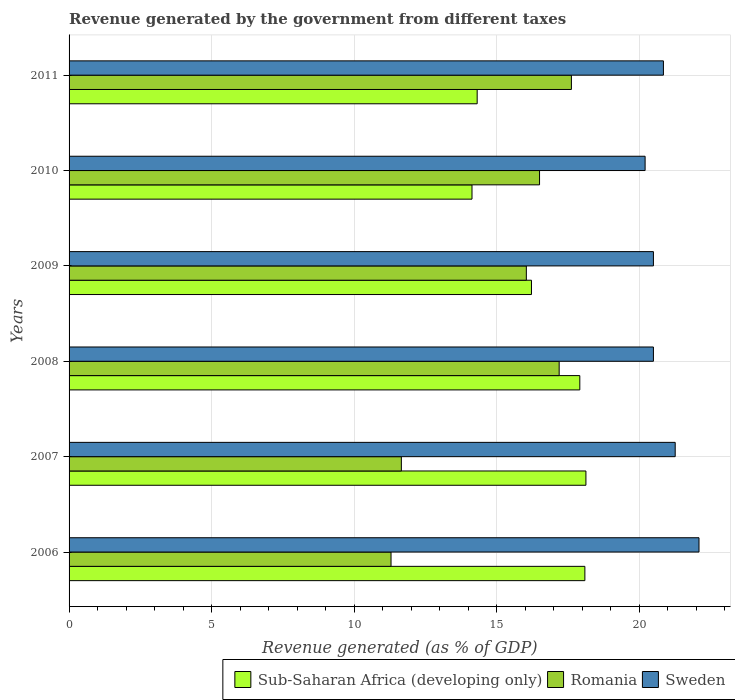How many different coloured bars are there?
Offer a very short reply. 3. How many groups of bars are there?
Keep it short and to the point. 6. Are the number of bars on each tick of the Y-axis equal?
Provide a succinct answer. Yes. How many bars are there on the 2nd tick from the top?
Your answer should be compact. 3. How many bars are there on the 1st tick from the bottom?
Offer a very short reply. 3. In how many cases, is the number of bars for a given year not equal to the number of legend labels?
Offer a terse response. 0. What is the revenue generated by the government in Romania in 2010?
Your answer should be very brief. 16.5. Across all years, what is the maximum revenue generated by the government in Sub-Saharan Africa (developing only)?
Provide a short and direct response. 18.13. Across all years, what is the minimum revenue generated by the government in Sweden?
Make the answer very short. 20.21. In which year was the revenue generated by the government in Sub-Saharan Africa (developing only) maximum?
Your response must be concise. 2007. In which year was the revenue generated by the government in Sweden minimum?
Offer a very short reply. 2010. What is the total revenue generated by the government in Romania in the graph?
Your answer should be compact. 90.3. What is the difference between the revenue generated by the government in Sub-Saharan Africa (developing only) in 2008 and that in 2010?
Keep it short and to the point. 3.78. What is the difference between the revenue generated by the government in Sub-Saharan Africa (developing only) in 2009 and the revenue generated by the government in Sweden in 2008?
Your answer should be compact. -4.28. What is the average revenue generated by the government in Sweden per year?
Your answer should be very brief. 20.9. In the year 2009, what is the difference between the revenue generated by the government in Sub-Saharan Africa (developing only) and revenue generated by the government in Sweden?
Your response must be concise. -4.28. In how many years, is the revenue generated by the government in Sweden greater than 20 %?
Keep it short and to the point. 6. What is the ratio of the revenue generated by the government in Sweden in 2008 to that in 2009?
Your answer should be compact. 1. Is the revenue generated by the government in Sub-Saharan Africa (developing only) in 2009 less than that in 2010?
Make the answer very short. No. Is the difference between the revenue generated by the government in Sub-Saharan Africa (developing only) in 2006 and 2009 greater than the difference between the revenue generated by the government in Sweden in 2006 and 2009?
Keep it short and to the point. Yes. What is the difference between the highest and the second highest revenue generated by the government in Romania?
Offer a terse response. 0.43. What is the difference between the highest and the lowest revenue generated by the government in Sub-Saharan Africa (developing only)?
Provide a short and direct response. 4. Is the sum of the revenue generated by the government in Romania in 2008 and 2010 greater than the maximum revenue generated by the government in Sweden across all years?
Your answer should be compact. Yes. What does the 2nd bar from the top in 2006 represents?
Your response must be concise. Romania. What does the 1st bar from the bottom in 2011 represents?
Give a very brief answer. Sub-Saharan Africa (developing only). Are all the bars in the graph horizontal?
Your answer should be very brief. Yes. What is the difference between two consecutive major ticks on the X-axis?
Give a very brief answer. 5. Does the graph contain any zero values?
Your answer should be compact. No. Where does the legend appear in the graph?
Provide a succinct answer. Bottom right. What is the title of the graph?
Provide a succinct answer. Revenue generated by the government from different taxes. Does "Upper middle income" appear as one of the legend labels in the graph?
Give a very brief answer. No. What is the label or title of the X-axis?
Your response must be concise. Revenue generated (as % of GDP). What is the label or title of the Y-axis?
Provide a short and direct response. Years. What is the Revenue generated (as % of GDP) of Sub-Saharan Africa (developing only) in 2006?
Your answer should be compact. 18.09. What is the Revenue generated (as % of GDP) in Romania in 2006?
Your response must be concise. 11.29. What is the Revenue generated (as % of GDP) in Sweden in 2006?
Your answer should be compact. 22.1. What is the Revenue generated (as % of GDP) of Sub-Saharan Africa (developing only) in 2007?
Provide a succinct answer. 18.13. What is the Revenue generated (as % of GDP) of Romania in 2007?
Give a very brief answer. 11.66. What is the Revenue generated (as % of GDP) of Sweden in 2007?
Your answer should be very brief. 21.26. What is the Revenue generated (as % of GDP) of Sub-Saharan Africa (developing only) in 2008?
Provide a short and direct response. 17.92. What is the Revenue generated (as % of GDP) in Romania in 2008?
Your answer should be very brief. 17.19. What is the Revenue generated (as % of GDP) in Sweden in 2008?
Offer a very short reply. 20.5. What is the Revenue generated (as % of GDP) of Sub-Saharan Africa (developing only) in 2009?
Provide a short and direct response. 16.22. What is the Revenue generated (as % of GDP) of Romania in 2009?
Offer a very short reply. 16.04. What is the Revenue generated (as % of GDP) of Sweden in 2009?
Offer a very short reply. 20.5. What is the Revenue generated (as % of GDP) in Sub-Saharan Africa (developing only) in 2010?
Your response must be concise. 14.13. What is the Revenue generated (as % of GDP) of Romania in 2010?
Give a very brief answer. 16.5. What is the Revenue generated (as % of GDP) in Sweden in 2010?
Make the answer very short. 20.21. What is the Revenue generated (as % of GDP) in Sub-Saharan Africa (developing only) in 2011?
Provide a short and direct response. 14.31. What is the Revenue generated (as % of GDP) of Romania in 2011?
Your answer should be compact. 17.62. What is the Revenue generated (as % of GDP) of Sweden in 2011?
Your answer should be compact. 20.85. Across all years, what is the maximum Revenue generated (as % of GDP) in Sub-Saharan Africa (developing only)?
Provide a succinct answer. 18.13. Across all years, what is the maximum Revenue generated (as % of GDP) in Romania?
Offer a terse response. 17.62. Across all years, what is the maximum Revenue generated (as % of GDP) of Sweden?
Provide a succinct answer. 22.1. Across all years, what is the minimum Revenue generated (as % of GDP) in Sub-Saharan Africa (developing only)?
Provide a short and direct response. 14.13. Across all years, what is the minimum Revenue generated (as % of GDP) in Romania?
Provide a short and direct response. 11.29. Across all years, what is the minimum Revenue generated (as % of GDP) of Sweden?
Provide a short and direct response. 20.21. What is the total Revenue generated (as % of GDP) in Sub-Saharan Africa (developing only) in the graph?
Your answer should be compact. 98.81. What is the total Revenue generated (as % of GDP) of Romania in the graph?
Your answer should be compact. 90.3. What is the total Revenue generated (as % of GDP) in Sweden in the graph?
Your answer should be very brief. 125.41. What is the difference between the Revenue generated (as % of GDP) in Sub-Saharan Africa (developing only) in 2006 and that in 2007?
Make the answer very short. -0.04. What is the difference between the Revenue generated (as % of GDP) in Romania in 2006 and that in 2007?
Give a very brief answer. -0.36. What is the difference between the Revenue generated (as % of GDP) in Sweden in 2006 and that in 2007?
Offer a terse response. 0.83. What is the difference between the Revenue generated (as % of GDP) of Sub-Saharan Africa (developing only) in 2006 and that in 2008?
Provide a short and direct response. 0.18. What is the difference between the Revenue generated (as % of GDP) of Romania in 2006 and that in 2008?
Provide a succinct answer. -5.9. What is the difference between the Revenue generated (as % of GDP) of Sweden in 2006 and that in 2008?
Offer a very short reply. 1.6. What is the difference between the Revenue generated (as % of GDP) of Sub-Saharan Africa (developing only) in 2006 and that in 2009?
Your response must be concise. 1.87. What is the difference between the Revenue generated (as % of GDP) of Romania in 2006 and that in 2009?
Your response must be concise. -4.75. What is the difference between the Revenue generated (as % of GDP) in Sweden in 2006 and that in 2009?
Offer a very short reply. 1.6. What is the difference between the Revenue generated (as % of GDP) of Sub-Saharan Africa (developing only) in 2006 and that in 2010?
Ensure brevity in your answer.  3.96. What is the difference between the Revenue generated (as % of GDP) in Romania in 2006 and that in 2010?
Your answer should be very brief. -5.21. What is the difference between the Revenue generated (as % of GDP) in Sweden in 2006 and that in 2010?
Provide a succinct answer. 1.89. What is the difference between the Revenue generated (as % of GDP) of Sub-Saharan Africa (developing only) in 2006 and that in 2011?
Your answer should be very brief. 3.78. What is the difference between the Revenue generated (as % of GDP) in Romania in 2006 and that in 2011?
Your answer should be compact. -6.33. What is the difference between the Revenue generated (as % of GDP) in Sweden in 2006 and that in 2011?
Keep it short and to the point. 1.25. What is the difference between the Revenue generated (as % of GDP) in Sub-Saharan Africa (developing only) in 2007 and that in 2008?
Make the answer very short. 0.21. What is the difference between the Revenue generated (as % of GDP) of Romania in 2007 and that in 2008?
Offer a very short reply. -5.54. What is the difference between the Revenue generated (as % of GDP) in Sweden in 2007 and that in 2008?
Give a very brief answer. 0.76. What is the difference between the Revenue generated (as % of GDP) of Sub-Saharan Africa (developing only) in 2007 and that in 2009?
Keep it short and to the point. 1.91. What is the difference between the Revenue generated (as % of GDP) in Romania in 2007 and that in 2009?
Your answer should be very brief. -4.38. What is the difference between the Revenue generated (as % of GDP) in Sweden in 2007 and that in 2009?
Your answer should be very brief. 0.76. What is the difference between the Revenue generated (as % of GDP) of Sub-Saharan Africa (developing only) in 2007 and that in 2010?
Your answer should be compact. 4. What is the difference between the Revenue generated (as % of GDP) of Romania in 2007 and that in 2010?
Your response must be concise. -4.85. What is the difference between the Revenue generated (as % of GDP) of Sweden in 2007 and that in 2010?
Ensure brevity in your answer.  1.06. What is the difference between the Revenue generated (as % of GDP) of Sub-Saharan Africa (developing only) in 2007 and that in 2011?
Ensure brevity in your answer.  3.81. What is the difference between the Revenue generated (as % of GDP) of Romania in 2007 and that in 2011?
Provide a short and direct response. -5.96. What is the difference between the Revenue generated (as % of GDP) of Sweden in 2007 and that in 2011?
Your answer should be compact. 0.41. What is the difference between the Revenue generated (as % of GDP) of Sub-Saharan Africa (developing only) in 2008 and that in 2009?
Your answer should be very brief. 1.7. What is the difference between the Revenue generated (as % of GDP) of Romania in 2008 and that in 2009?
Offer a very short reply. 1.15. What is the difference between the Revenue generated (as % of GDP) in Sweden in 2008 and that in 2009?
Make the answer very short. 0. What is the difference between the Revenue generated (as % of GDP) of Sub-Saharan Africa (developing only) in 2008 and that in 2010?
Provide a succinct answer. 3.78. What is the difference between the Revenue generated (as % of GDP) in Romania in 2008 and that in 2010?
Ensure brevity in your answer.  0.69. What is the difference between the Revenue generated (as % of GDP) of Sweden in 2008 and that in 2010?
Offer a very short reply. 0.29. What is the difference between the Revenue generated (as % of GDP) in Sub-Saharan Africa (developing only) in 2008 and that in 2011?
Your answer should be very brief. 3.6. What is the difference between the Revenue generated (as % of GDP) of Romania in 2008 and that in 2011?
Offer a very short reply. -0.43. What is the difference between the Revenue generated (as % of GDP) in Sweden in 2008 and that in 2011?
Make the answer very short. -0.35. What is the difference between the Revenue generated (as % of GDP) in Sub-Saharan Africa (developing only) in 2009 and that in 2010?
Offer a very short reply. 2.09. What is the difference between the Revenue generated (as % of GDP) of Romania in 2009 and that in 2010?
Your answer should be very brief. -0.46. What is the difference between the Revenue generated (as % of GDP) in Sweden in 2009 and that in 2010?
Provide a succinct answer. 0.29. What is the difference between the Revenue generated (as % of GDP) in Sub-Saharan Africa (developing only) in 2009 and that in 2011?
Provide a short and direct response. 1.9. What is the difference between the Revenue generated (as % of GDP) in Romania in 2009 and that in 2011?
Provide a succinct answer. -1.58. What is the difference between the Revenue generated (as % of GDP) in Sweden in 2009 and that in 2011?
Make the answer very short. -0.35. What is the difference between the Revenue generated (as % of GDP) of Sub-Saharan Africa (developing only) in 2010 and that in 2011?
Keep it short and to the point. -0.18. What is the difference between the Revenue generated (as % of GDP) in Romania in 2010 and that in 2011?
Provide a succinct answer. -1.12. What is the difference between the Revenue generated (as % of GDP) in Sweden in 2010 and that in 2011?
Offer a very short reply. -0.64. What is the difference between the Revenue generated (as % of GDP) in Sub-Saharan Africa (developing only) in 2006 and the Revenue generated (as % of GDP) in Romania in 2007?
Offer a terse response. 6.44. What is the difference between the Revenue generated (as % of GDP) in Sub-Saharan Africa (developing only) in 2006 and the Revenue generated (as % of GDP) in Sweden in 2007?
Offer a terse response. -3.17. What is the difference between the Revenue generated (as % of GDP) of Romania in 2006 and the Revenue generated (as % of GDP) of Sweden in 2007?
Keep it short and to the point. -9.97. What is the difference between the Revenue generated (as % of GDP) in Sub-Saharan Africa (developing only) in 2006 and the Revenue generated (as % of GDP) in Romania in 2008?
Offer a very short reply. 0.9. What is the difference between the Revenue generated (as % of GDP) in Sub-Saharan Africa (developing only) in 2006 and the Revenue generated (as % of GDP) in Sweden in 2008?
Your answer should be compact. -2.4. What is the difference between the Revenue generated (as % of GDP) of Romania in 2006 and the Revenue generated (as % of GDP) of Sweden in 2008?
Your response must be concise. -9.2. What is the difference between the Revenue generated (as % of GDP) in Sub-Saharan Africa (developing only) in 2006 and the Revenue generated (as % of GDP) in Romania in 2009?
Keep it short and to the point. 2.05. What is the difference between the Revenue generated (as % of GDP) of Sub-Saharan Africa (developing only) in 2006 and the Revenue generated (as % of GDP) of Sweden in 2009?
Provide a short and direct response. -2.4. What is the difference between the Revenue generated (as % of GDP) of Romania in 2006 and the Revenue generated (as % of GDP) of Sweden in 2009?
Make the answer very short. -9.2. What is the difference between the Revenue generated (as % of GDP) of Sub-Saharan Africa (developing only) in 2006 and the Revenue generated (as % of GDP) of Romania in 2010?
Your answer should be very brief. 1.59. What is the difference between the Revenue generated (as % of GDP) in Sub-Saharan Africa (developing only) in 2006 and the Revenue generated (as % of GDP) in Sweden in 2010?
Offer a very short reply. -2.11. What is the difference between the Revenue generated (as % of GDP) in Romania in 2006 and the Revenue generated (as % of GDP) in Sweden in 2010?
Give a very brief answer. -8.91. What is the difference between the Revenue generated (as % of GDP) in Sub-Saharan Africa (developing only) in 2006 and the Revenue generated (as % of GDP) in Romania in 2011?
Make the answer very short. 0.47. What is the difference between the Revenue generated (as % of GDP) of Sub-Saharan Africa (developing only) in 2006 and the Revenue generated (as % of GDP) of Sweden in 2011?
Keep it short and to the point. -2.75. What is the difference between the Revenue generated (as % of GDP) of Romania in 2006 and the Revenue generated (as % of GDP) of Sweden in 2011?
Offer a very short reply. -9.55. What is the difference between the Revenue generated (as % of GDP) in Sub-Saharan Africa (developing only) in 2007 and the Revenue generated (as % of GDP) in Romania in 2008?
Offer a terse response. 0.94. What is the difference between the Revenue generated (as % of GDP) of Sub-Saharan Africa (developing only) in 2007 and the Revenue generated (as % of GDP) of Sweden in 2008?
Provide a succinct answer. -2.37. What is the difference between the Revenue generated (as % of GDP) in Romania in 2007 and the Revenue generated (as % of GDP) in Sweden in 2008?
Provide a succinct answer. -8.84. What is the difference between the Revenue generated (as % of GDP) of Sub-Saharan Africa (developing only) in 2007 and the Revenue generated (as % of GDP) of Romania in 2009?
Make the answer very short. 2.09. What is the difference between the Revenue generated (as % of GDP) of Sub-Saharan Africa (developing only) in 2007 and the Revenue generated (as % of GDP) of Sweden in 2009?
Offer a very short reply. -2.37. What is the difference between the Revenue generated (as % of GDP) of Romania in 2007 and the Revenue generated (as % of GDP) of Sweden in 2009?
Provide a succinct answer. -8.84. What is the difference between the Revenue generated (as % of GDP) in Sub-Saharan Africa (developing only) in 2007 and the Revenue generated (as % of GDP) in Romania in 2010?
Your answer should be compact. 1.63. What is the difference between the Revenue generated (as % of GDP) in Sub-Saharan Africa (developing only) in 2007 and the Revenue generated (as % of GDP) in Sweden in 2010?
Offer a terse response. -2.08. What is the difference between the Revenue generated (as % of GDP) in Romania in 2007 and the Revenue generated (as % of GDP) in Sweden in 2010?
Your answer should be very brief. -8.55. What is the difference between the Revenue generated (as % of GDP) of Sub-Saharan Africa (developing only) in 2007 and the Revenue generated (as % of GDP) of Romania in 2011?
Give a very brief answer. 0.51. What is the difference between the Revenue generated (as % of GDP) in Sub-Saharan Africa (developing only) in 2007 and the Revenue generated (as % of GDP) in Sweden in 2011?
Offer a terse response. -2.72. What is the difference between the Revenue generated (as % of GDP) of Romania in 2007 and the Revenue generated (as % of GDP) of Sweden in 2011?
Keep it short and to the point. -9.19. What is the difference between the Revenue generated (as % of GDP) in Sub-Saharan Africa (developing only) in 2008 and the Revenue generated (as % of GDP) in Romania in 2009?
Provide a short and direct response. 1.88. What is the difference between the Revenue generated (as % of GDP) in Sub-Saharan Africa (developing only) in 2008 and the Revenue generated (as % of GDP) in Sweden in 2009?
Your response must be concise. -2.58. What is the difference between the Revenue generated (as % of GDP) in Romania in 2008 and the Revenue generated (as % of GDP) in Sweden in 2009?
Offer a very short reply. -3.31. What is the difference between the Revenue generated (as % of GDP) in Sub-Saharan Africa (developing only) in 2008 and the Revenue generated (as % of GDP) in Romania in 2010?
Ensure brevity in your answer.  1.41. What is the difference between the Revenue generated (as % of GDP) of Sub-Saharan Africa (developing only) in 2008 and the Revenue generated (as % of GDP) of Sweden in 2010?
Provide a short and direct response. -2.29. What is the difference between the Revenue generated (as % of GDP) in Romania in 2008 and the Revenue generated (as % of GDP) in Sweden in 2010?
Your answer should be compact. -3.01. What is the difference between the Revenue generated (as % of GDP) of Sub-Saharan Africa (developing only) in 2008 and the Revenue generated (as % of GDP) of Romania in 2011?
Offer a very short reply. 0.29. What is the difference between the Revenue generated (as % of GDP) of Sub-Saharan Africa (developing only) in 2008 and the Revenue generated (as % of GDP) of Sweden in 2011?
Offer a very short reply. -2.93. What is the difference between the Revenue generated (as % of GDP) of Romania in 2008 and the Revenue generated (as % of GDP) of Sweden in 2011?
Ensure brevity in your answer.  -3.66. What is the difference between the Revenue generated (as % of GDP) in Sub-Saharan Africa (developing only) in 2009 and the Revenue generated (as % of GDP) in Romania in 2010?
Provide a succinct answer. -0.28. What is the difference between the Revenue generated (as % of GDP) of Sub-Saharan Africa (developing only) in 2009 and the Revenue generated (as % of GDP) of Sweden in 2010?
Offer a very short reply. -3.99. What is the difference between the Revenue generated (as % of GDP) of Romania in 2009 and the Revenue generated (as % of GDP) of Sweden in 2010?
Your response must be concise. -4.17. What is the difference between the Revenue generated (as % of GDP) in Sub-Saharan Africa (developing only) in 2009 and the Revenue generated (as % of GDP) in Romania in 2011?
Provide a succinct answer. -1.4. What is the difference between the Revenue generated (as % of GDP) of Sub-Saharan Africa (developing only) in 2009 and the Revenue generated (as % of GDP) of Sweden in 2011?
Your response must be concise. -4.63. What is the difference between the Revenue generated (as % of GDP) of Romania in 2009 and the Revenue generated (as % of GDP) of Sweden in 2011?
Offer a very short reply. -4.81. What is the difference between the Revenue generated (as % of GDP) in Sub-Saharan Africa (developing only) in 2010 and the Revenue generated (as % of GDP) in Romania in 2011?
Provide a short and direct response. -3.49. What is the difference between the Revenue generated (as % of GDP) of Sub-Saharan Africa (developing only) in 2010 and the Revenue generated (as % of GDP) of Sweden in 2011?
Make the answer very short. -6.71. What is the difference between the Revenue generated (as % of GDP) of Romania in 2010 and the Revenue generated (as % of GDP) of Sweden in 2011?
Give a very brief answer. -4.34. What is the average Revenue generated (as % of GDP) in Sub-Saharan Africa (developing only) per year?
Offer a very short reply. 16.47. What is the average Revenue generated (as % of GDP) in Romania per year?
Provide a short and direct response. 15.05. What is the average Revenue generated (as % of GDP) in Sweden per year?
Offer a terse response. 20.9. In the year 2006, what is the difference between the Revenue generated (as % of GDP) in Sub-Saharan Africa (developing only) and Revenue generated (as % of GDP) in Romania?
Offer a terse response. 6.8. In the year 2006, what is the difference between the Revenue generated (as % of GDP) in Sub-Saharan Africa (developing only) and Revenue generated (as % of GDP) in Sweden?
Your answer should be very brief. -4. In the year 2006, what is the difference between the Revenue generated (as % of GDP) of Romania and Revenue generated (as % of GDP) of Sweden?
Ensure brevity in your answer.  -10.8. In the year 2007, what is the difference between the Revenue generated (as % of GDP) of Sub-Saharan Africa (developing only) and Revenue generated (as % of GDP) of Romania?
Provide a short and direct response. 6.47. In the year 2007, what is the difference between the Revenue generated (as % of GDP) of Sub-Saharan Africa (developing only) and Revenue generated (as % of GDP) of Sweden?
Your answer should be very brief. -3.13. In the year 2007, what is the difference between the Revenue generated (as % of GDP) of Romania and Revenue generated (as % of GDP) of Sweden?
Offer a terse response. -9.61. In the year 2008, what is the difference between the Revenue generated (as % of GDP) in Sub-Saharan Africa (developing only) and Revenue generated (as % of GDP) in Romania?
Offer a terse response. 0.72. In the year 2008, what is the difference between the Revenue generated (as % of GDP) of Sub-Saharan Africa (developing only) and Revenue generated (as % of GDP) of Sweden?
Keep it short and to the point. -2.58. In the year 2008, what is the difference between the Revenue generated (as % of GDP) in Romania and Revenue generated (as % of GDP) in Sweden?
Keep it short and to the point. -3.31. In the year 2009, what is the difference between the Revenue generated (as % of GDP) in Sub-Saharan Africa (developing only) and Revenue generated (as % of GDP) in Romania?
Offer a terse response. 0.18. In the year 2009, what is the difference between the Revenue generated (as % of GDP) in Sub-Saharan Africa (developing only) and Revenue generated (as % of GDP) in Sweden?
Your answer should be very brief. -4.28. In the year 2009, what is the difference between the Revenue generated (as % of GDP) in Romania and Revenue generated (as % of GDP) in Sweden?
Your response must be concise. -4.46. In the year 2010, what is the difference between the Revenue generated (as % of GDP) in Sub-Saharan Africa (developing only) and Revenue generated (as % of GDP) in Romania?
Your answer should be compact. -2.37. In the year 2010, what is the difference between the Revenue generated (as % of GDP) in Sub-Saharan Africa (developing only) and Revenue generated (as % of GDP) in Sweden?
Provide a succinct answer. -6.07. In the year 2010, what is the difference between the Revenue generated (as % of GDP) in Romania and Revenue generated (as % of GDP) in Sweden?
Offer a terse response. -3.7. In the year 2011, what is the difference between the Revenue generated (as % of GDP) in Sub-Saharan Africa (developing only) and Revenue generated (as % of GDP) in Romania?
Offer a very short reply. -3.31. In the year 2011, what is the difference between the Revenue generated (as % of GDP) of Sub-Saharan Africa (developing only) and Revenue generated (as % of GDP) of Sweden?
Ensure brevity in your answer.  -6.53. In the year 2011, what is the difference between the Revenue generated (as % of GDP) of Romania and Revenue generated (as % of GDP) of Sweden?
Give a very brief answer. -3.23. What is the ratio of the Revenue generated (as % of GDP) in Sub-Saharan Africa (developing only) in 2006 to that in 2007?
Your response must be concise. 1. What is the ratio of the Revenue generated (as % of GDP) in Romania in 2006 to that in 2007?
Your answer should be compact. 0.97. What is the ratio of the Revenue generated (as % of GDP) of Sweden in 2006 to that in 2007?
Keep it short and to the point. 1.04. What is the ratio of the Revenue generated (as % of GDP) of Sub-Saharan Africa (developing only) in 2006 to that in 2008?
Your response must be concise. 1.01. What is the ratio of the Revenue generated (as % of GDP) of Romania in 2006 to that in 2008?
Provide a short and direct response. 0.66. What is the ratio of the Revenue generated (as % of GDP) in Sweden in 2006 to that in 2008?
Ensure brevity in your answer.  1.08. What is the ratio of the Revenue generated (as % of GDP) of Sub-Saharan Africa (developing only) in 2006 to that in 2009?
Your answer should be compact. 1.12. What is the ratio of the Revenue generated (as % of GDP) in Romania in 2006 to that in 2009?
Ensure brevity in your answer.  0.7. What is the ratio of the Revenue generated (as % of GDP) of Sweden in 2006 to that in 2009?
Your answer should be compact. 1.08. What is the ratio of the Revenue generated (as % of GDP) of Sub-Saharan Africa (developing only) in 2006 to that in 2010?
Provide a succinct answer. 1.28. What is the ratio of the Revenue generated (as % of GDP) of Romania in 2006 to that in 2010?
Provide a succinct answer. 0.68. What is the ratio of the Revenue generated (as % of GDP) of Sweden in 2006 to that in 2010?
Provide a short and direct response. 1.09. What is the ratio of the Revenue generated (as % of GDP) of Sub-Saharan Africa (developing only) in 2006 to that in 2011?
Ensure brevity in your answer.  1.26. What is the ratio of the Revenue generated (as % of GDP) in Romania in 2006 to that in 2011?
Offer a very short reply. 0.64. What is the ratio of the Revenue generated (as % of GDP) in Sweden in 2006 to that in 2011?
Your answer should be very brief. 1.06. What is the ratio of the Revenue generated (as % of GDP) of Sub-Saharan Africa (developing only) in 2007 to that in 2008?
Ensure brevity in your answer.  1.01. What is the ratio of the Revenue generated (as % of GDP) of Romania in 2007 to that in 2008?
Make the answer very short. 0.68. What is the ratio of the Revenue generated (as % of GDP) of Sweden in 2007 to that in 2008?
Give a very brief answer. 1.04. What is the ratio of the Revenue generated (as % of GDP) of Sub-Saharan Africa (developing only) in 2007 to that in 2009?
Give a very brief answer. 1.12. What is the ratio of the Revenue generated (as % of GDP) in Romania in 2007 to that in 2009?
Offer a very short reply. 0.73. What is the ratio of the Revenue generated (as % of GDP) in Sweden in 2007 to that in 2009?
Ensure brevity in your answer.  1.04. What is the ratio of the Revenue generated (as % of GDP) in Sub-Saharan Africa (developing only) in 2007 to that in 2010?
Offer a very short reply. 1.28. What is the ratio of the Revenue generated (as % of GDP) of Romania in 2007 to that in 2010?
Keep it short and to the point. 0.71. What is the ratio of the Revenue generated (as % of GDP) in Sweden in 2007 to that in 2010?
Your answer should be compact. 1.05. What is the ratio of the Revenue generated (as % of GDP) in Sub-Saharan Africa (developing only) in 2007 to that in 2011?
Offer a very short reply. 1.27. What is the ratio of the Revenue generated (as % of GDP) of Romania in 2007 to that in 2011?
Offer a terse response. 0.66. What is the ratio of the Revenue generated (as % of GDP) in Sweden in 2007 to that in 2011?
Your answer should be very brief. 1.02. What is the ratio of the Revenue generated (as % of GDP) in Sub-Saharan Africa (developing only) in 2008 to that in 2009?
Provide a succinct answer. 1.1. What is the ratio of the Revenue generated (as % of GDP) in Romania in 2008 to that in 2009?
Make the answer very short. 1.07. What is the ratio of the Revenue generated (as % of GDP) of Sweden in 2008 to that in 2009?
Provide a succinct answer. 1. What is the ratio of the Revenue generated (as % of GDP) in Sub-Saharan Africa (developing only) in 2008 to that in 2010?
Give a very brief answer. 1.27. What is the ratio of the Revenue generated (as % of GDP) in Romania in 2008 to that in 2010?
Your response must be concise. 1.04. What is the ratio of the Revenue generated (as % of GDP) in Sweden in 2008 to that in 2010?
Provide a succinct answer. 1.01. What is the ratio of the Revenue generated (as % of GDP) of Sub-Saharan Africa (developing only) in 2008 to that in 2011?
Provide a short and direct response. 1.25. What is the ratio of the Revenue generated (as % of GDP) in Romania in 2008 to that in 2011?
Keep it short and to the point. 0.98. What is the ratio of the Revenue generated (as % of GDP) in Sweden in 2008 to that in 2011?
Your answer should be very brief. 0.98. What is the ratio of the Revenue generated (as % of GDP) of Sub-Saharan Africa (developing only) in 2009 to that in 2010?
Your response must be concise. 1.15. What is the ratio of the Revenue generated (as % of GDP) of Romania in 2009 to that in 2010?
Ensure brevity in your answer.  0.97. What is the ratio of the Revenue generated (as % of GDP) of Sweden in 2009 to that in 2010?
Your answer should be very brief. 1.01. What is the ratio of the Revenue generated (as % of GDP) of Sub-Saharan Africa (developing only) in 2009 to that in 2011?
Offer a terse response. 1.13. What is the ratio of the Revenue generated (as % of GDP) of Romania in 2009 to that in 2011?
Keep it short and to the point. 0.91. What is the ratio of the Revenue generated (as % of GDP) in Sweden in 2009 to that in 2011?
Your answer should be very brief. 0.98. What is the ratio of the Revenue generated (as % of GDP) in Sub-Saharan Africa (developing only) in 2010 to that in 2011?
Offer a terse response. 0.99. What is the ratio of the Revenue generated (as % of GDP) of Romania in 2010 to that in 2011?
Provide a succinct answer. 0.94. What is the ratio of the Revenue generated (as % of GDP) in Sweden in 2010 to that in 2011?
Provide a succinct answer. 0.97. What is the difference between the highest and the second highest Revenue generated (as % of GDP) of Sub-Saharan Africa (developing only)?
Give a very brief answer. 0.04. What is the difference between the highest and the second highest Revenue generated (as % of GDP) of Romania?
Your answer should be very brief. 0.43. What is the difference between the highest and the second highest Revenue generated (as % of GDP) of Sweden?
Give a very brief answer. 0.83. What is the difference between the highest and the lowest Revenue generated (as % of GDP) of Sub-Saharan Africa (developing only)?
Give a very brief answer. 4. What is the difference between the highest and the lowest Revenue generated (as % of GDP) in Romania?
Your response must be concise. 6.33. What is the difference between the highest and the lowest Revenue generated (as % of GDP) of Sweden?
Make the answer very short. 1.89. 